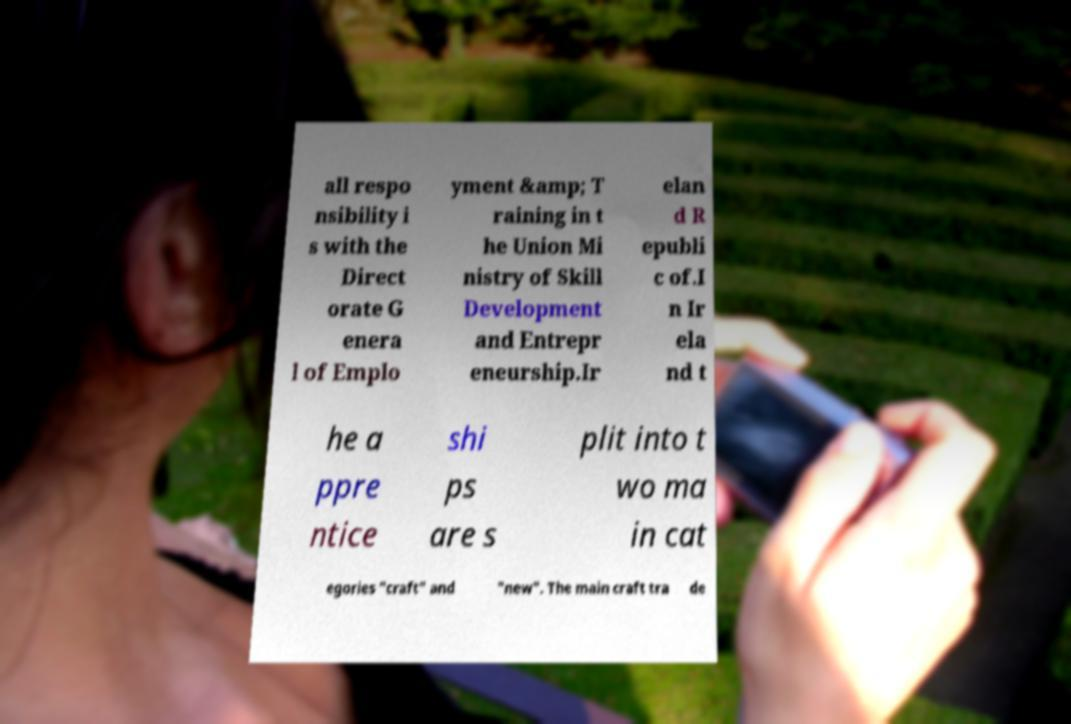Can you read and provide the text displayed in the image?This photo seems to have some interesting text. Can you extract and type it out for me? all respo nsibility i s with the Direct orate G enera l of Emplo yment &amp; T raining in t he Union Mi nistry of Skill Development and Entrepr eneurship.Ir elan d R epubli c of.I n Ir ela nd t he a ppre ntice shi ps are s plit into t wo ma in cat egories "craft" and "new". The main craft tra de 